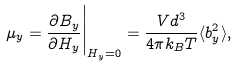Convert formula to latex. <formula><loc_0><loc_0><loc_500><loc_500>\mu _ { y } = \frac { \partial B _ { y } } { \partial H _ { y } } \Big | _ { H _ { y } = 0 } = \frac { V d ^ { 3 } } { 4 \pi k _ { B } T } \langle b _ { y } ^ { 2 } \rangle ,</formula> 